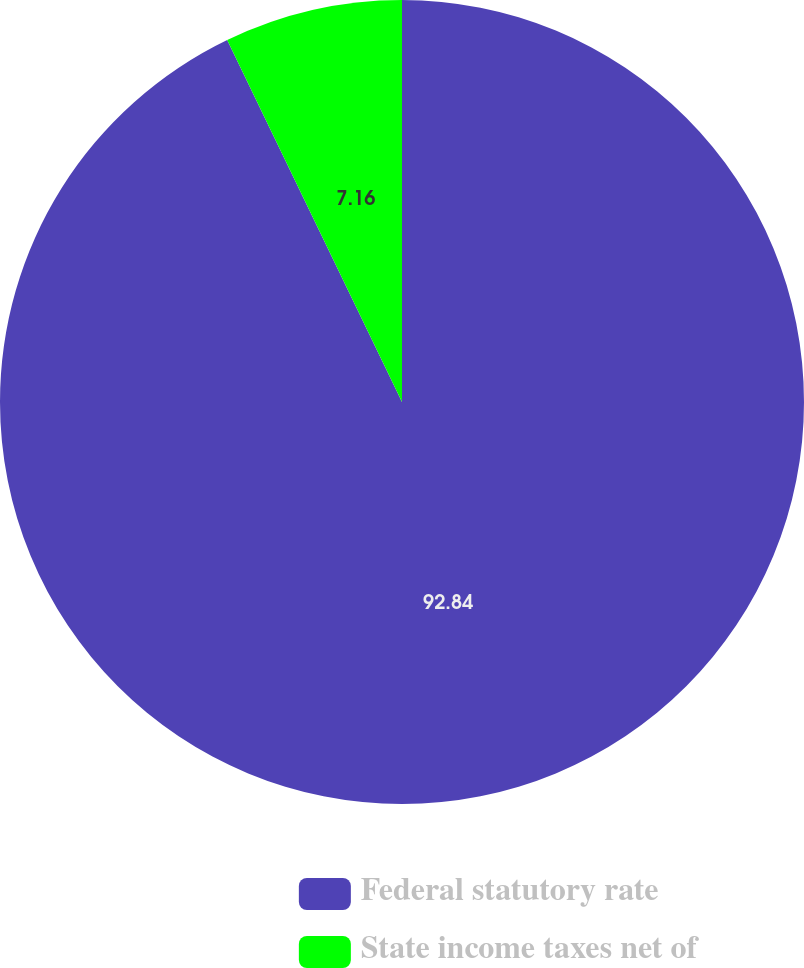Convert chart. <chart><loc_0><loc_0><loc_500><loc_500><pie_chart><fcel>Federal statutory rate<fcel>State income taxes net of<nl><fcel>92.84%<fcel>7.16%<nl></chart> 